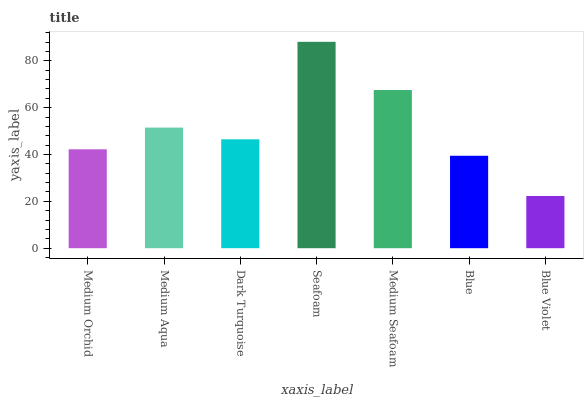Is Blue Violet the minimum?
Answer yes or no. Yes. Is Seafoam the maximum?
Answer yes or no. Yes. Is Medium Aqua the minimum?
Answer yes or no. No. Is Medium Aqua the maximum?
Answer yes or no. No. Is Medium Aqua greater than Medium Orchid?
Answer yes or no. Yes. Is Medium Orchid less than Medium Aqua?
Answer yes or no. Yes. Is Medium Orchid greater than Medium Aqua?
Answer yes or no. No. Is Medium Aqua less than Medium Orchid?
Answer yes or no. No. Is Dark Turquoise the high median?
Answer yes or no. Yes. Is Dark Turquoise the low median?
Answer yes or no. Yes. Is Medium Aqua the high median?
Answer yes or no. No. Is Blue Violet the low median?
Answer yes or no. No. 